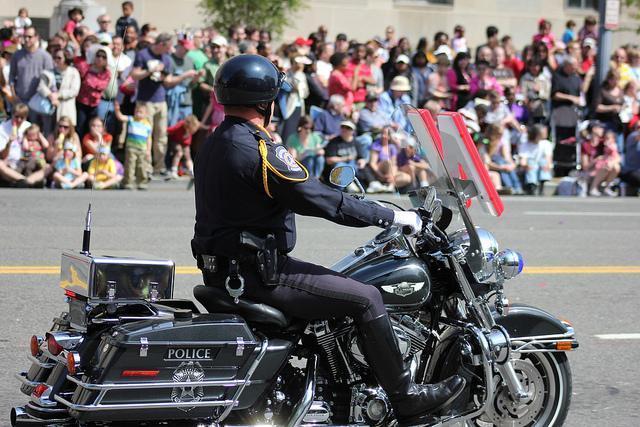How many bikers are wearing red?
Give a very brief answer. 0. How many people are visible?
Give a very brief answer. 5. 